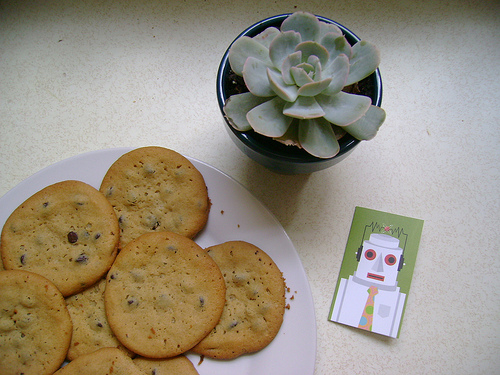<image>
Can you confirm if the plant is on the plate? No. The plant is not positioned on the plate. They may be near each other, but the plant is not supported by or resting on top of the plate. 